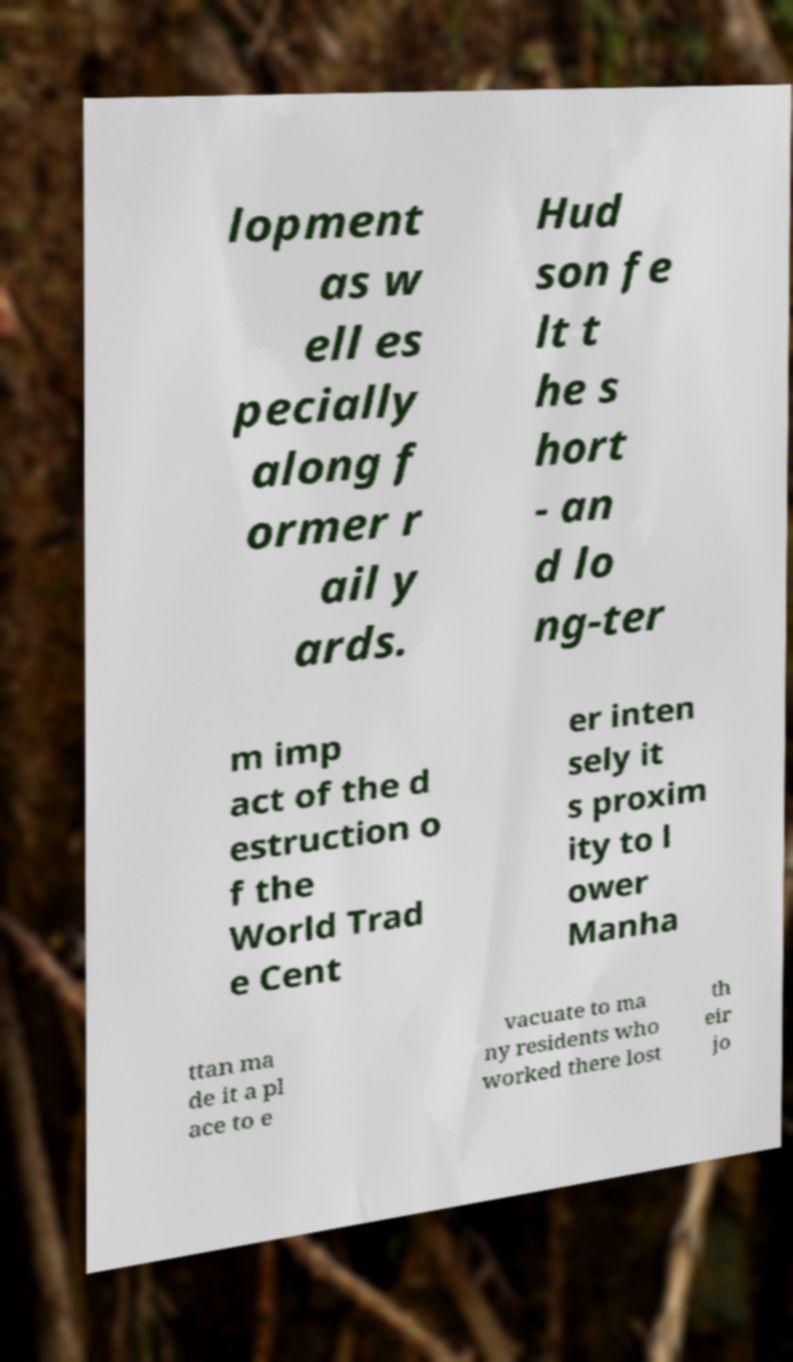What messages or text are displayed in this image? I need them in a readable, typed format. lopment as w ell es pecially along f ormer r ail y ards. Hud son fe lt t he s hort - an d lo ng-ter m imp act of the d estruction o f the World Trad e Cent er inten sely it s proxim ity to l ower Manha ttan ma de it a pl ace to e vacuate to ma ny residents who worked there lost th eir jo 